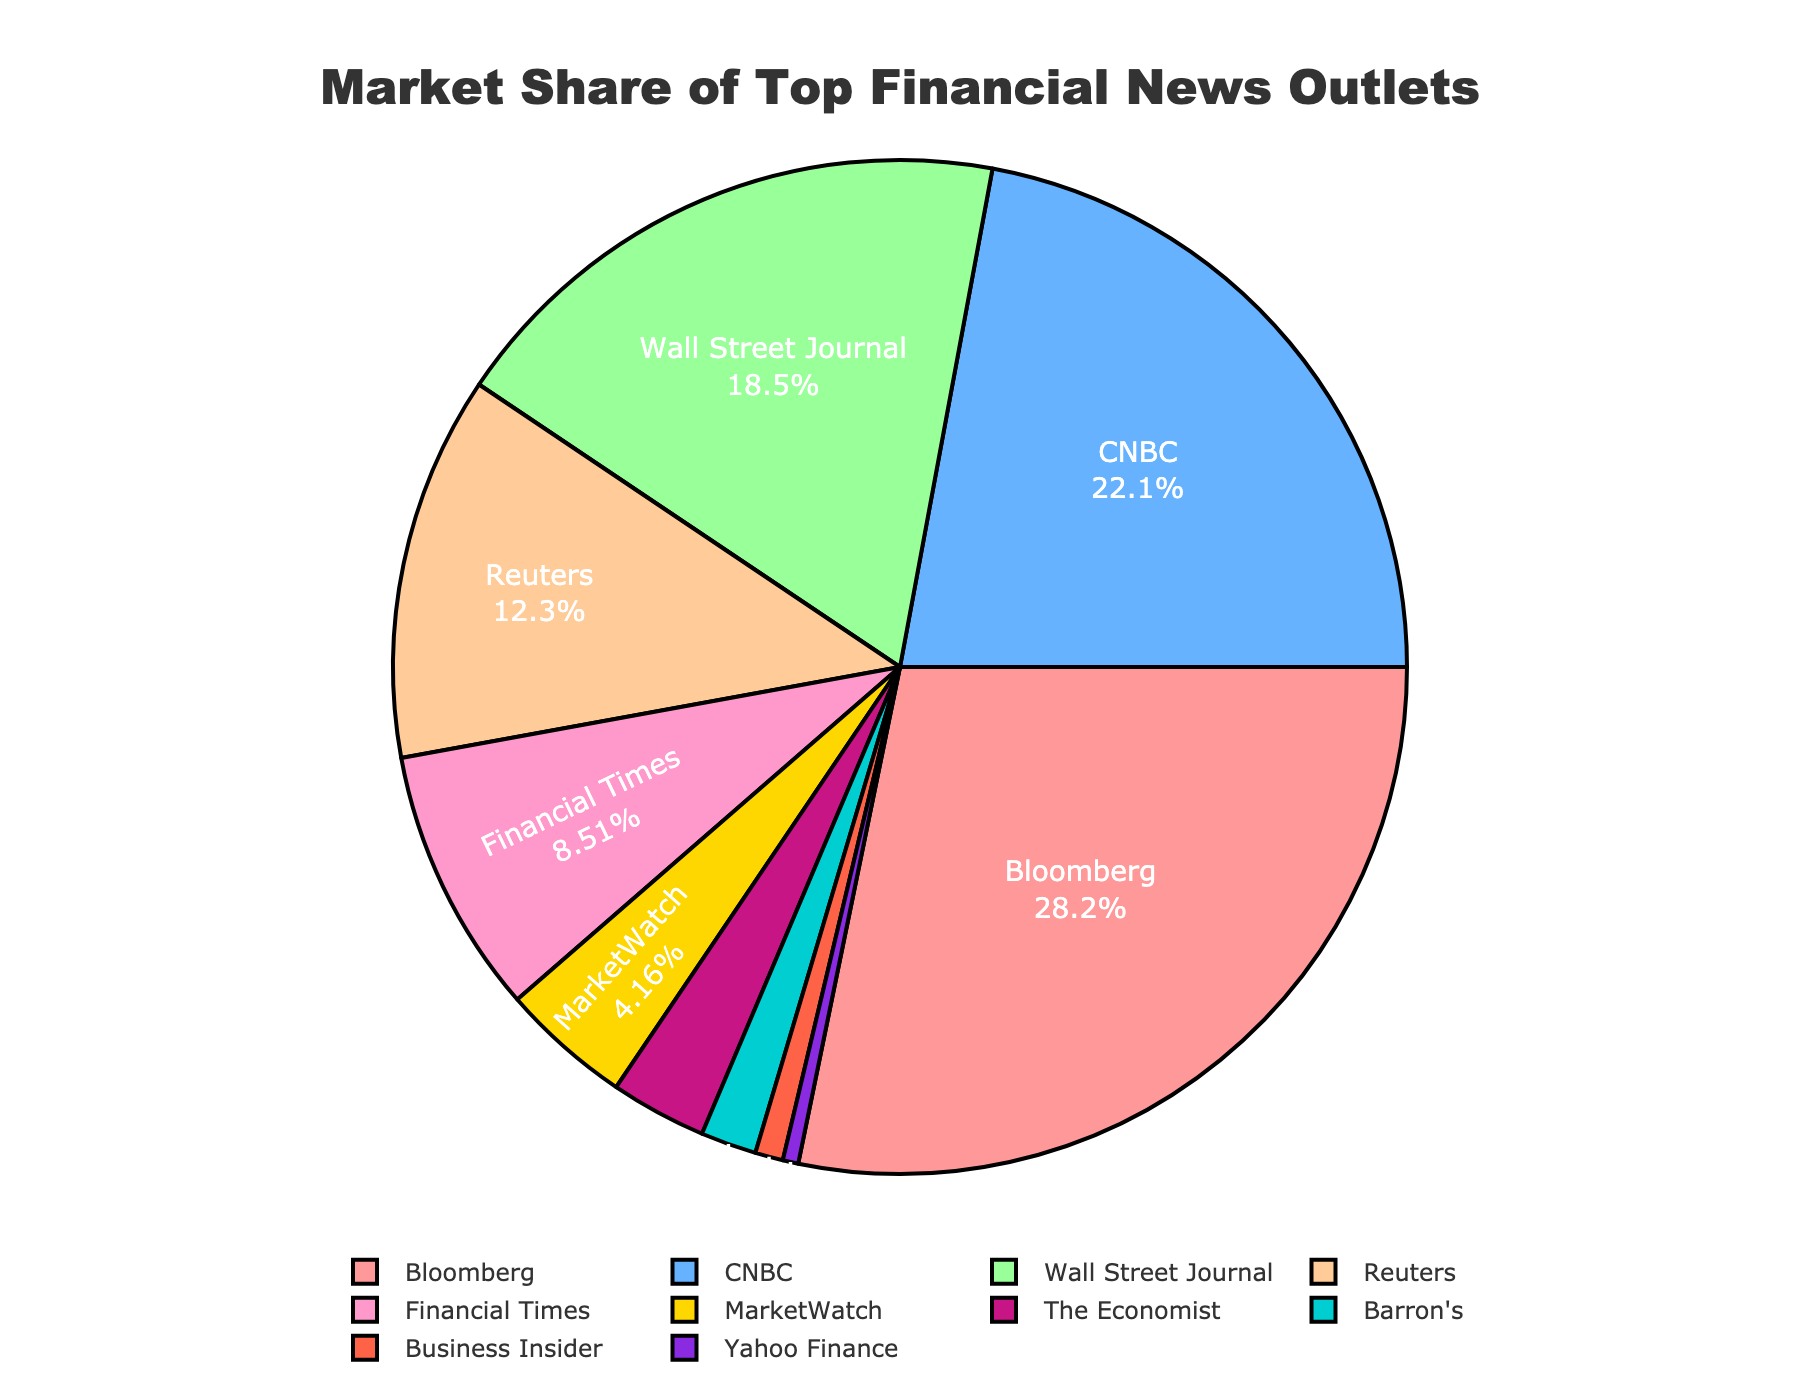Which outlet has the largest market share? The outlet with the largest market share can be identified directly from the pie chart, where the segment representing Bloomberg occupies the largest portion of the chart.
Answer: Bloomberg How much greater is Bloomberg's market share than Business Insider's? To find how much greater Bloomberg's market share is than Business Insider’s, subtract Business Insider's market share from Bloomberg's: 28.5% - 0.9% = 27.6%
Answer: 27.6% Which three outlets together account for more than half of the market share? Identify the outlets with the highest market shares and sum them up until the total exceeds 50%. Bloomberg (28.5%), CNBC (22.3%), and Wall Street Journal (18.7%) together have a combined market share of 28.5% + 22.3% + 18.7% = 69.5%, which is more than half.
Answer: Bloomberg, CNBC, Wall Street Journal What is the total market share of outlets with less than 10% market share each? Sum the market shares of Financial Times (8.6%), MarketWatch (4.2%), The Economist (3.1%), Barron's (1.8%), Business Insider (0.9%), and Yahoo Finance (0.5%): 8.6% + 4.2% + 3.1% + 1.8% + 0.9% + 0.5% = 19.1%
Answer: 19.1% Which outlet has the smallest market share and what color represents it in the chart? The outlet with the smallest market share is Yahoo Finance (0.5%). Identify the color of its segment in the pie chart, which is represented by a distinct color in the provided color scheme.
Answer: Yahoo Finance, dark blue Compare the market shares of CNBC and Financial Times. How many times larger is CNBC's market share than Financial Times'? To find how many times larger CNBC's market share is compared to Financial Times', divide CNBC’s market share by that of Financial Times: 22.3% / 8.6% ≈ 2.6 times
Answer: Approximately 2.6 times What is the combined market share of the outlets shown in shades of red and pink? Identify the outlets represented in shades of red and pink, including Bloomberg (28.5%) and Barron's (1.8%), then sum their market shares: 28.5% + 1.8% = 30.3%
Answer: 30.3% Between Reuters and Wall Street Journal, which has the greater market share and by how much? Compare the market shares of Reuters (12.4%) and Wall Street Journal (18.7%). Subtract Reuters' market share from Wall Street Journal's: 18.7% - 12.4% = 6.3%
Answer: Wall Street Journal by 6.3% 